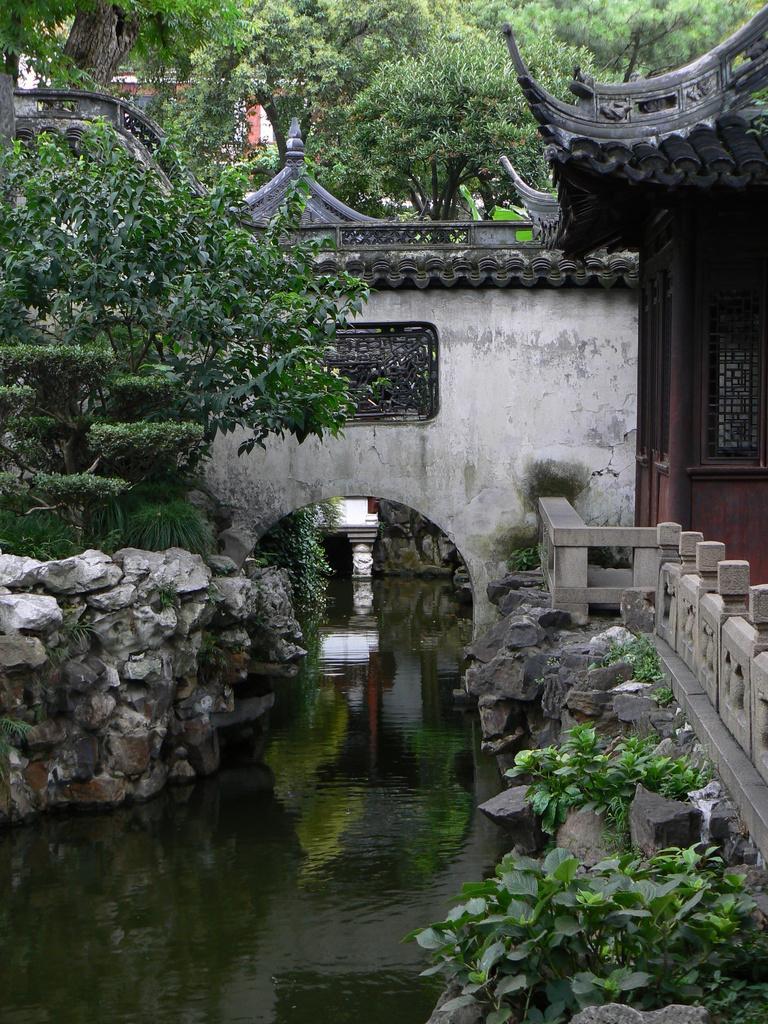Please provide a concise description of this image. In this picture I can see there is a canal and there are rocks into left and right. There is a building on to right and there are plants and trees in the backdrop. 